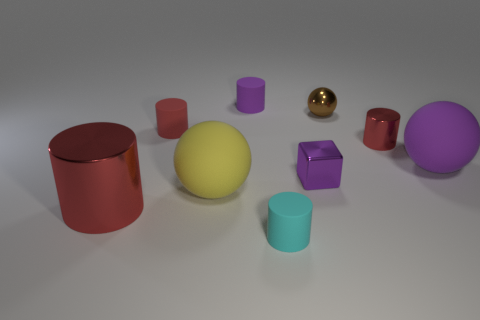Can you describe the color distribution of the objects in this image? Certainly! The image displays a rich assortment of colors among the various objects. There is a prominent yellow sphere at the center, flanked by objects in red, purple, teal, and a shiny gold. The colors are well distributed across the scene, providing a vibrant and balanced visual appeal. 